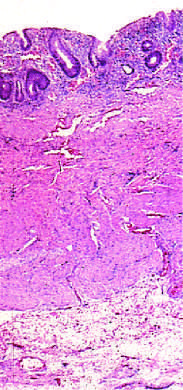what is limited to the mucosa?
Answer the question using a single word or phrase. Disease 